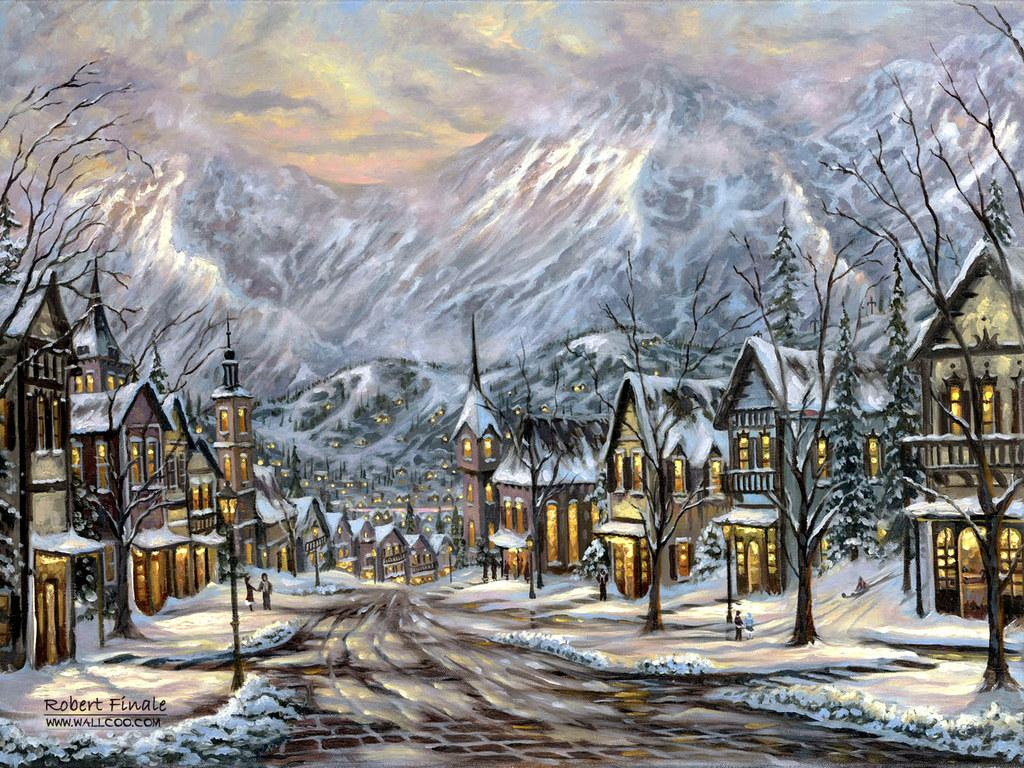What type of image is being described? The image is graphical in nature. What structures can be seen in the image? There are poles, buildings, and trees in the image. What type of landscape features are present in the image? There are hills in the image. What natural elements can be seen in the image? There are clouds in the image, and the sky is visible. How many tickets are visible in the image? There are no tickets present in the image. Who is the expert in the image? There is no expert depicted in the image. 